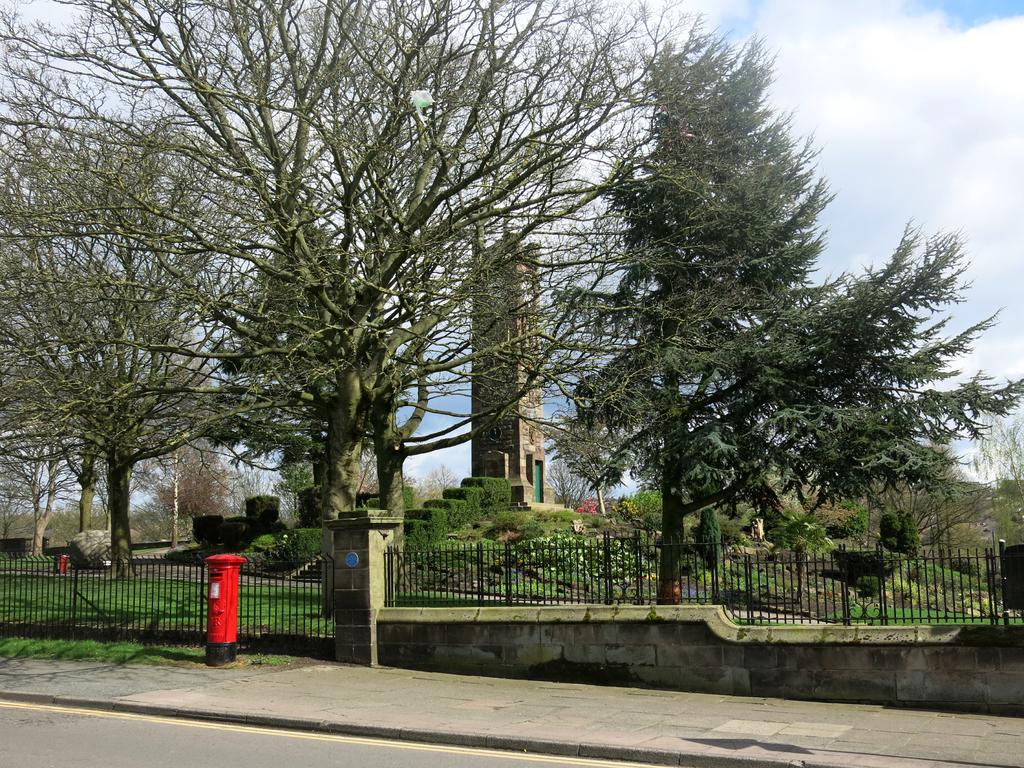What is located on the ground in the image? There is a post box on the ground in the image. What is beside the post box? There is a fence beside the post box. What type of natural elements can be seen in the image? Trees and plants are visible in the image. What type of structure can be seen in the image? There is a tower in the image. What else can be seen in the image besides the post box, fence, trees, and plants? There are some objects in the image. What is visible in the background of the image? The sky with clouds is visible in the background of the image. What is the rate of disgust in the image? There is no indication of disgust in the image, so it cannot be measured or rated. 